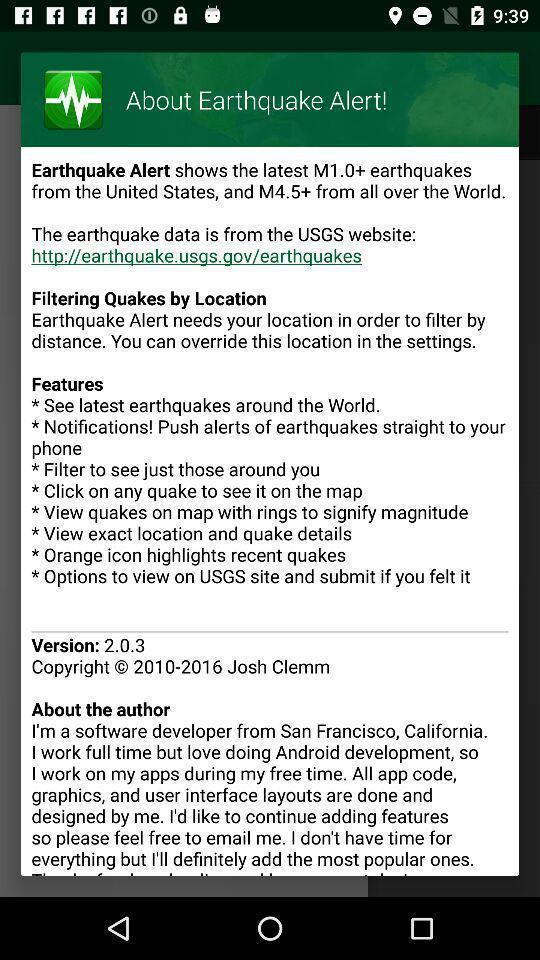Provide a description of this screenshot. Screen showing details about the app. 